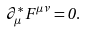Convert formula to latex. <formula><loc_0><loc_0><loc_500><loc_500>\partial _ { \mu } ^ { * } \, F ^ { \mu \nu } = 0 .</formula> 